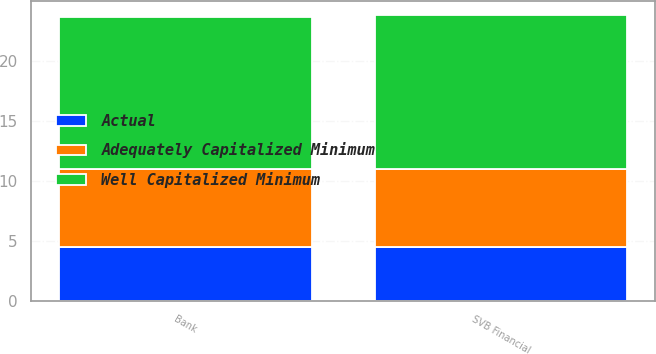<chart> <loc_0><loc_0><loc_500><loc_500><stacked_bar_chart><ecel><fcel>SVB Financial<fcel>Bank<nl><fcel>Well Capitalized Minimum<fcel>12.8<fcel>12.65<nl><fcel>Adequately Capitalized Minimum<fcel>6.5<fcel>6.5<nl><fcel>Actual<fcel>4.5<fcel>4.5<nl></chart> 